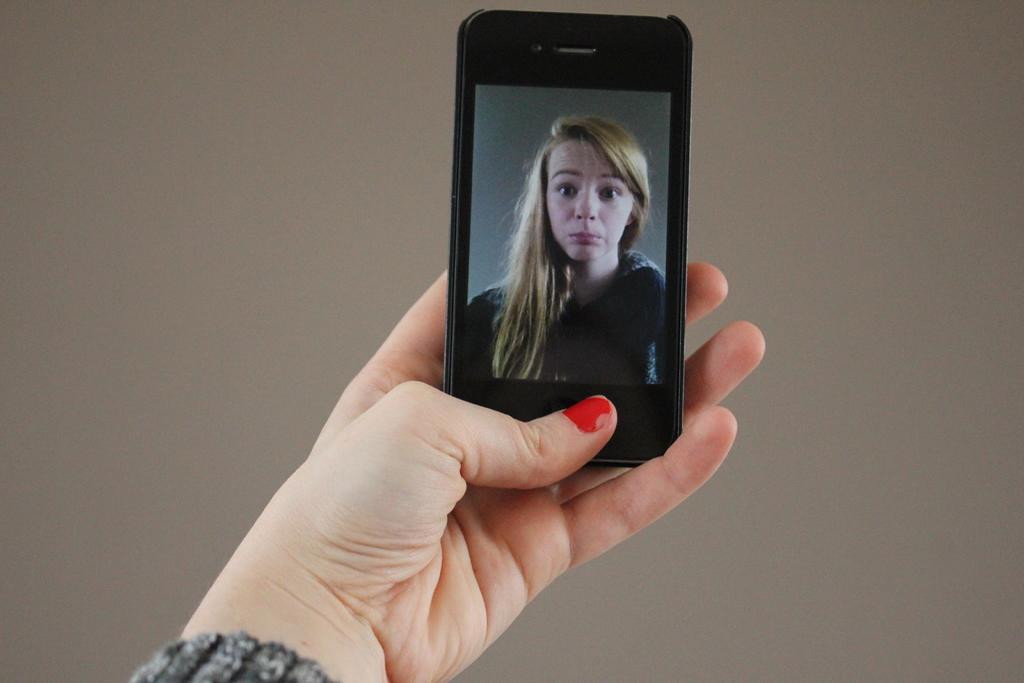Describe this image in one or two sentences. In this image there is a person's hand and in the hand, there is a mobile phone. On the mobile phone screen there is a picture of a woman. 